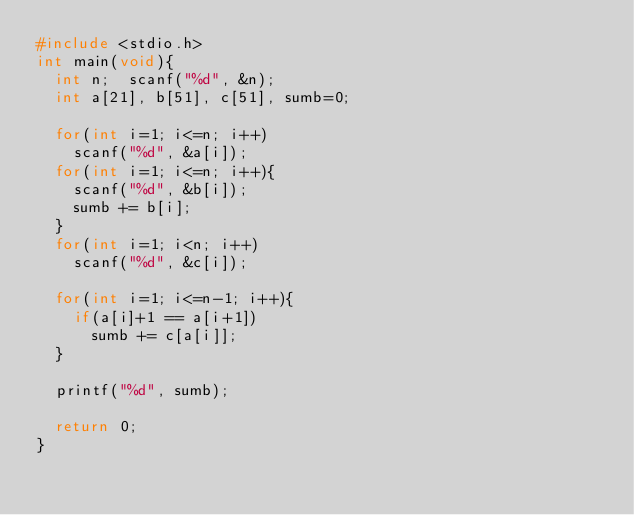<code> <loc_0><loc_0><loc_500><loc_500><_C_>#include <stdio.h>
int main(void){
  int n;  scanf("%d", &n);
  int a[21], b[51], c[51], sumb=0;
  
  for(int i=1; i<=n; i++)
    scanf("%d", &a[i]);
  for(int i=1; i<=n; i++){
    scanf("%d", &b[i]);
   	sumb += b[i];
  }
  for(int i=1; i<n; i++)
    scanf("%d", &c[i]);
  
  for(int i=1; i<=n-1; i++){
    if(a[i]+1 == a[i+1])
      sumb += c[a[i]];
  }
  
  printf("%d", sumb);
  
  return 0;
}
      </code> 